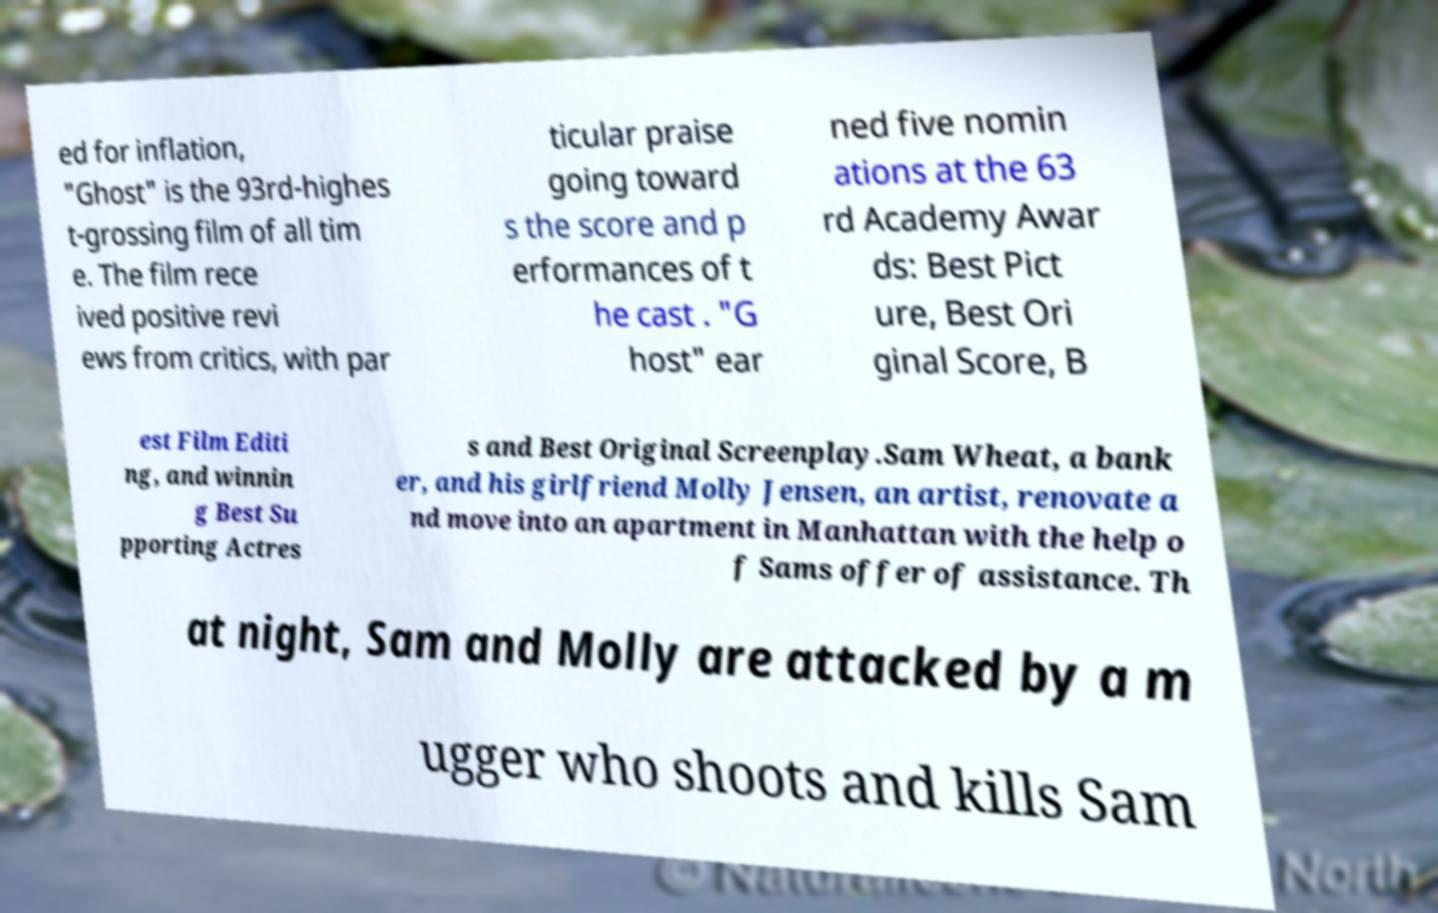There's text embedded in this image that I need extracted. Can you transcribe it verbatim? ed for inflation, "Ghost" is the 93rd-highes t-grossing film of all tim e. The film rece ived positive revi ews from critics, with par ticular praise going toward s the score and p erformances of t he cast . "G host" ear ned five nomin ations at the 63 rd Academy Awar ds: Best Pict ure, Best Ori ginal Score, B est Film Editi ng, and winnin g Best Su pporting Actres s and Best Original Screenplay.Sam Wheat, a bank er, and his girlfriend Molly Jensen, an artist, renovate a nd move into an apartment in Manhattan with the help o f Sams offer of assistance. Th at night, Sam and Molly are attacked by a m ugger who shoots and kills Sam 